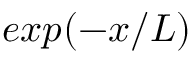Convert formula to latex. <formula><loc_0><loc_0><loc_500><loc_500>e x p ( - x / L )</formula> 